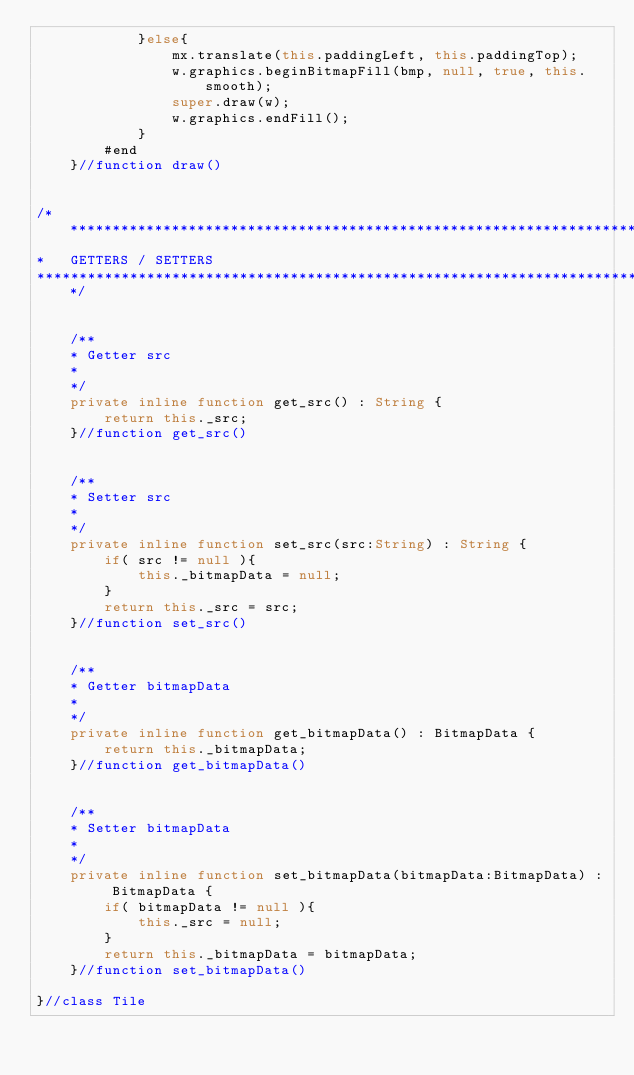Convert code to text. <code><loc_0><loc_0><loc_500><loc_500><_Haxe_>            }else{
                mx.translate(this.paddingLeft, this.paddingTop);
                w.graphics.beginBitmapFill(bmp, null, true, this.smooth);
                super.draw(w);
                w.graphics.endFill();
            }
        #end
    }//function draw()


/*******************************************************************************
*   GETTERS / SETTERS
*******************************************************************************/


    /**
    * Getter src
    *
    */
    private inline function get_src() : String {
        return this._src;
    }//function get_src()


    /**
    * Setter src
    *
    */
    private inline function set_src(src:String) : String {
        if( src != null ){
            this._bitmapData = null;
        }
        return this._src = src;
    }//function set_src()


    /**
    * Getter bitmapData
    *
    */
    private inline function get_bitmapData() : BitmapData {
        return this._bitmapData;
    }//function get_bitmapData()


    /**
    * Setter bitmapData
    *
    */
    private inline function set_bitmapData(bitmapData:BitmapData) : BitmapData {
        if( bitmapData != null ){
            this._src = null;
        }
        return this._bitmapData = bitmapData;
    }//function set_bitmapData()

}//class Tile</code> 